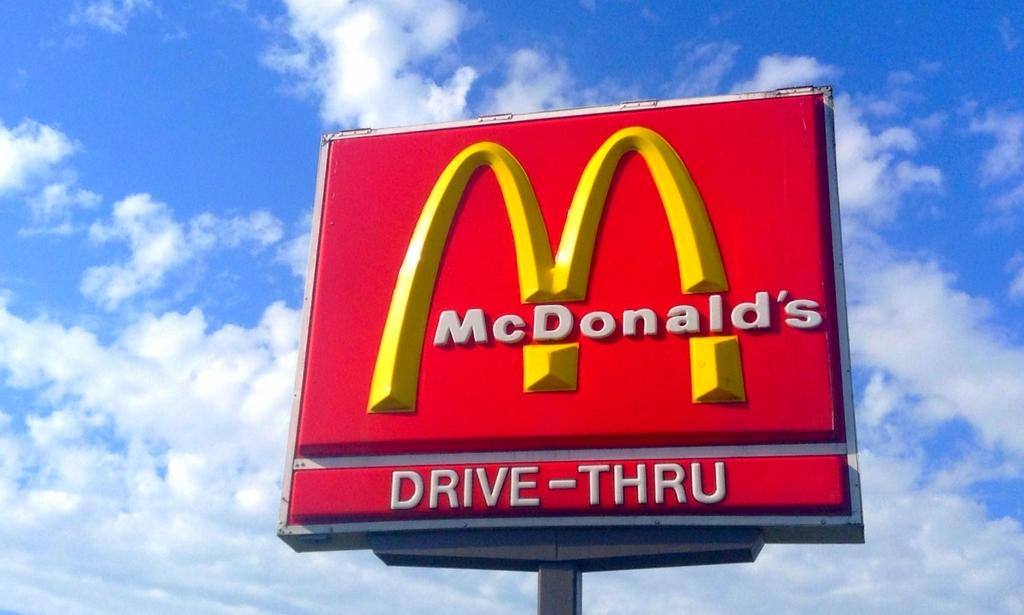Provide a one-sentence caption for the provided image. A McDonald's sign is shown with the golden arches and a Drive-Thru sign. 